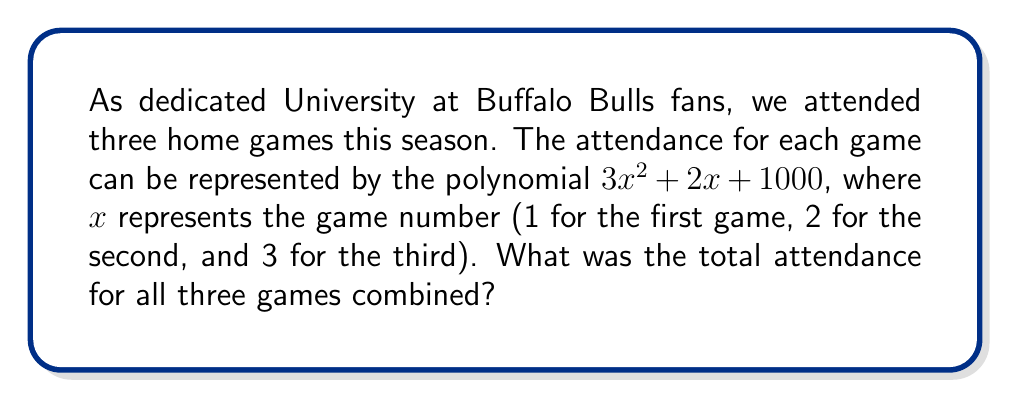Can you answer this question? To solve this problem, we need to evaluate the polynomial for each game and then add the results. Let's break it down step-by-step:

1. For the first game (x = 1):
   $3(1)^2 + 2(1) + 1000 = 3 + 2 + 1000 = 1005$

2. For the second game (x = 2):
   $3(2)^2 + 2(2) + 1000 = 12 + 4 + 1000 = 1016$

3. For the third game (x = 3):
   $3(3)^2 + 2(3) + 1000 = 27 + 6 + 1000 = 1033$

Now, we add the attendance for all three games:

$1005 + 1016 + 1033 = 3054$

Alternatively, we can solve this using polynomial addition:

$$(3x^2 + 2x + 1000) + (3x^2 + 2x + 1000) + (3x^2 + 2x + 1000)$$

Combining like terms:

$$9x^2 + 6x + 3000$$

Now, we evaluate this polynomial for x = 1, x = 2, and x = 3:

$$9(1^2 + 2^2 + 3^2) + 6(1 + 2 + 3) + 3000$$
$$= 9(14) + 6(6) + 3000$$
$$= 126 + 36 + 3000$$
$$= 3162$$

This method gives us the same result as adding the individual game attendances.
Answer: The total attendance for all three University at Buffalo Bulls home games combined was 3054 people. 